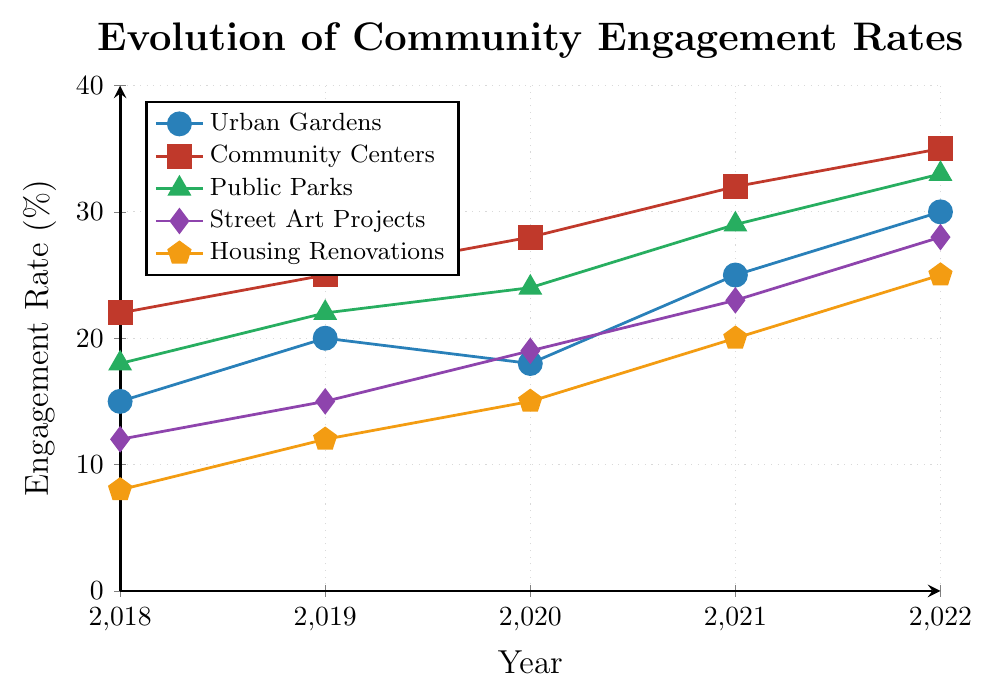What was the engagement rate for Urban Gardens in 2019? From the line representing Urban Gardens, find the point corresponding to the year 2019.
Answer: 20 Which project had the highest engagement rate in 2022? Look for the highest point on the graph for the year 2022.
Answer: Community Centers By how much did the engagement rate for Housing Renovations increase from 2018 to 2022? Find the engagement rates for Housing Renovations in 2018 and 2022, then subtract the 2018 value from the 2022 value. 25 - 8 = 17
Answer: 17 What is the average engagement rate for Public Parks over the 5 years? Sum the engagement rates for Public Parks from 2018 to 2022 and divide by the number of years (5). (18 + 22 + 24 + 29 + 33) / 5 = 25.2
Answer: 25.2 How many projects had an engagement rate of 30% or more in 2022? Check the engagement rates for each project in 2022 and count the number of projects with a rate of 30% or more.
Answer: 2 Between which two consecutive years did Community Centers see the highest increase in engagement rates? Calculate the year-to-year differences for Community Centers and identify the highest one. (2019 - 2018 = 3, 2020 - 2019 = 3, 2021 - 2020 = 4, 2022 - 2021 = 3)
Answer: 2020 to 2021 What is the overall trend for Street Art Projects from 2018 to 2022? Observe the trend line for Street Art Projects over the period.
Answer: Increasing What is the difference in engagement rate between the highest and lowest projects in 2021? Identify the highest and lowest engagement rates for 2021 and subtract the lowest from the highest. 32 (Community Centers) - 20 (Housing Renovations) = 12
Answer: 12 